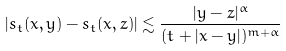Convert formula to latex. <formula><loc_0><loc_0><loc_500><loc_500>| s _ { t } ( x , y ) - s _ { t } ( x , z ) | \lesssim \frac { | y - z | ^ { \alpha } } { ( t + | x - y | ) ^ { m + \alpha } }</formula> 